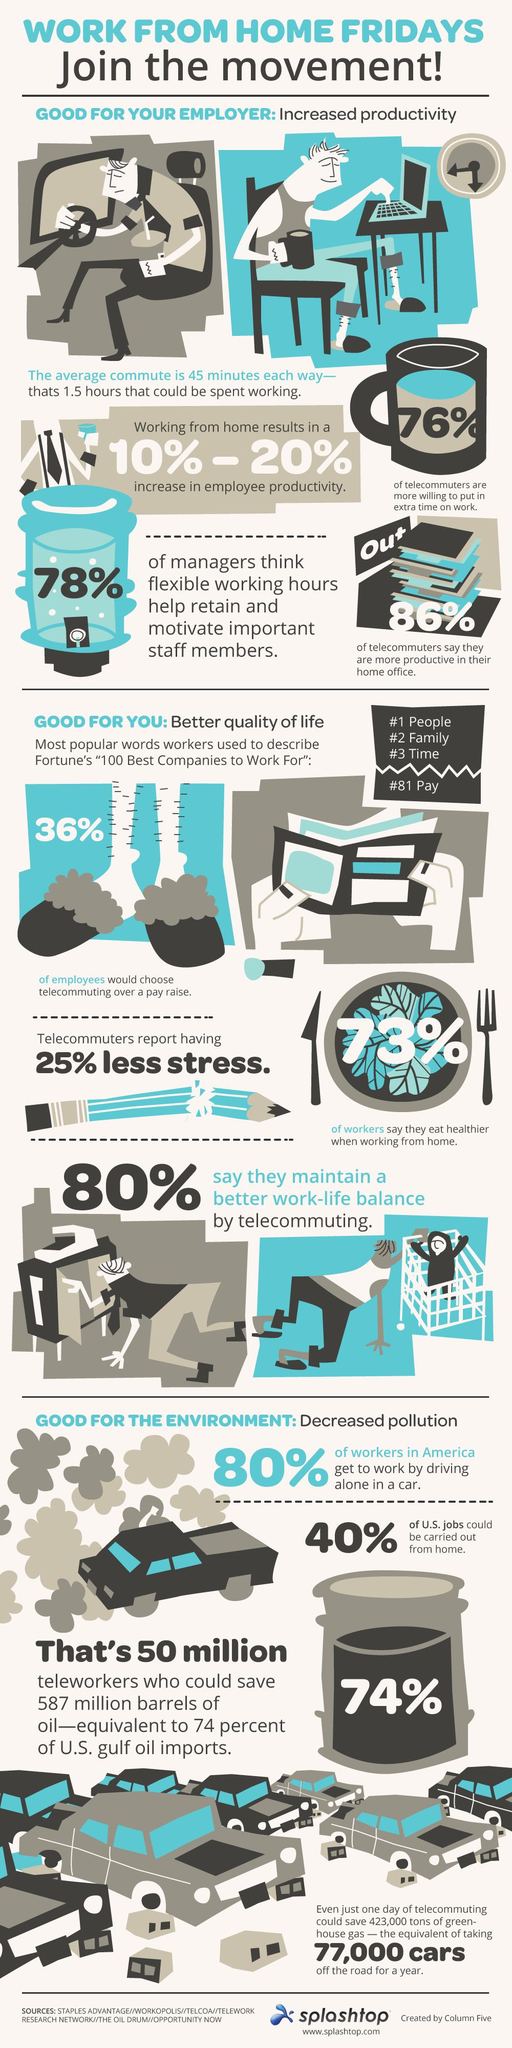Point out several critical features in this image. According to the given data, 36% of people would choose telecommuting over pay. Seventy-six percent of telecommuters are willing to do extra work. 